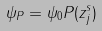Convert formula to latex. <formula><loc_0><loc_0><loc_500><loc_500>\psi _ { P } = \psi _ { 0 } P ( z _ { j } ^ { s } )</formula> 